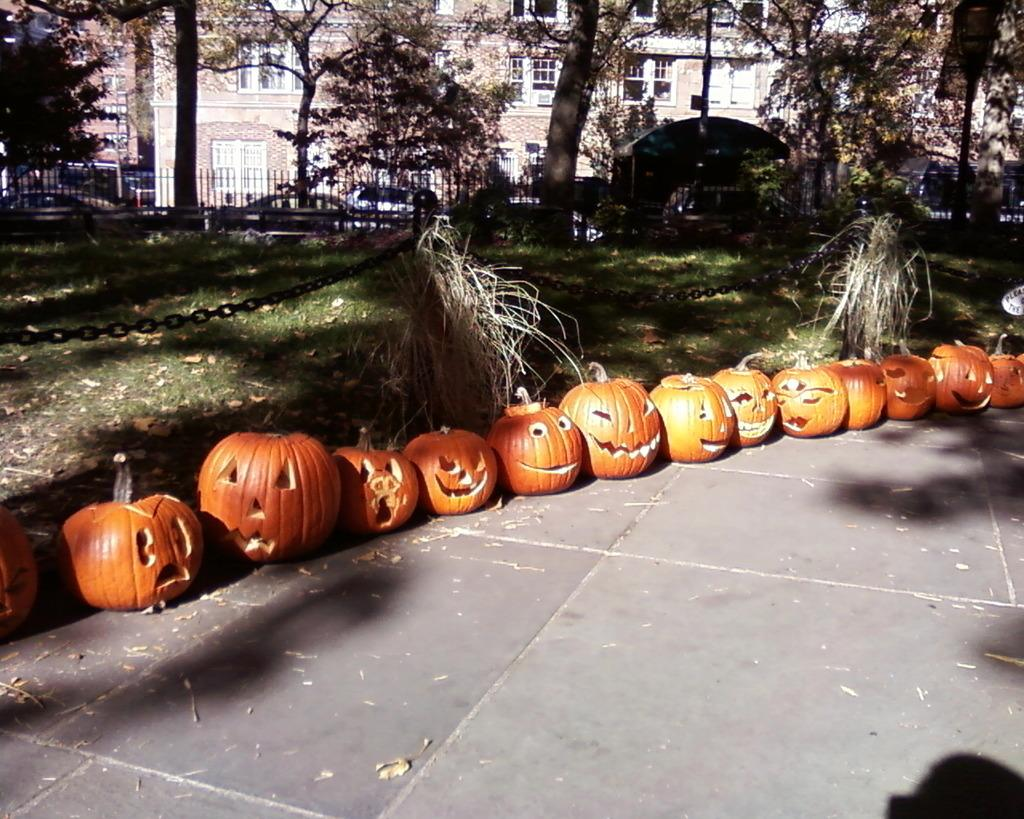What type of vegetation can be seen in the image? There are trees in the image. What type of structures are present in the image? There are buildings in the image. What type of vehicles are visible in the image? There are cars in the image. What type of barrier is present in the image? There is a fence in the image. What decorative items can be seen on the floor in the image? Carved pumpkins are placed on the floor. What type of ground surface is visible in the image? There is grass visible in the image. What type of restraining device is present in the image? There is a chain in the image. Where are the dinosaurs located in the image? There are no dinosaurs present in the image. What time of day is it in the image, based on the hour? The provided facts do not mention the time of day or any specific hour, so it cannot be determined from the image. 